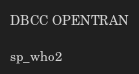Convert code to text. <code><loc_0><loc_0><loc_500><loc_500><_SQL_>
DBCC OPENTRAN

sp_who2</code> 